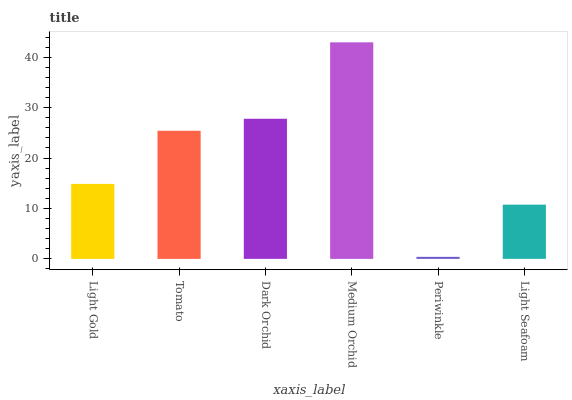Is Periwinkle the minimum?
Answer yes or no. Yes. Is Medium Orchid the maximum?
Answer yes or no. Yes. Is Tomato the minimum?
Answer yes or no. No. Is Tomato the maximum?
Answer yes or no. No. Is Tomato greater than Light Gold?
Answer yes or no. Yes. Is Light Gold less than Tomato?
Answer yes or no. Yes. Is Light Gold greater than Tomato?
Answer yes or no. No. Is Tomato less than Light Gold?
Answer yes or no. No. Is Tomato the high median?
Answer yes or no. Yes. Is Light Gold the low median?
Answer yes or no. Yes. Is Light Seafoam the high median?
Answer yes or no. No. Is Dark Orchid the low median?
Answer yes or no. No. 